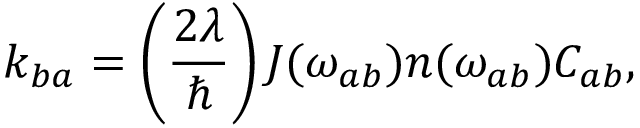<formula> <loc_0><loc_0><loc_500><loc_500>k _ { b a } = \left ( \frac { 2 \lambda } { } \right ) J ( \omega _ { a b } ) n ( \omega _ { a b } ) C _ { a b } ,</formula> 